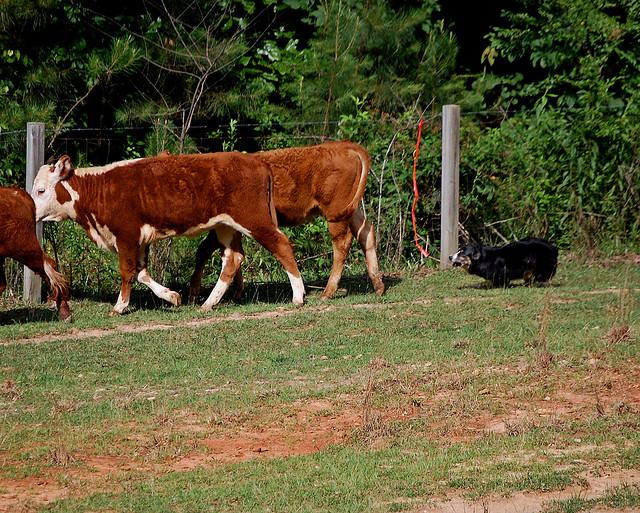Do you see a house?
Keep it brief. No. How many cows do you see?
Keep it brief. 3. What breed of dog is in this photograph?
Keep it brief. Cattle. How is the cow positioned?
Give a very brief answer. Facing left. Does the cow have spots?
Keep it brief. No. Are these cows full-grown?
Concise answer only. Yes. How many fence posts are visible?
Keep it brief. 2. What color is the small cow?
Concise answer only. Black. 